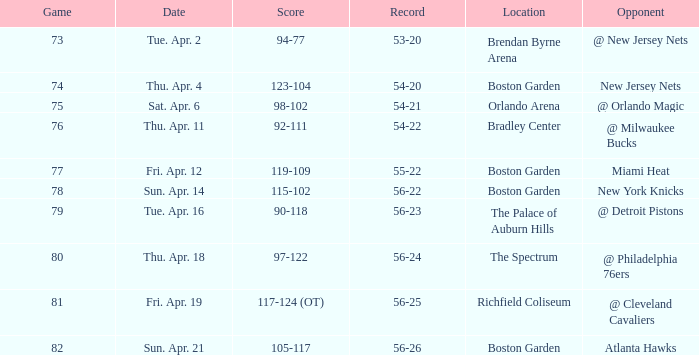When was the score 56-26? Sun. Apr. 21. 